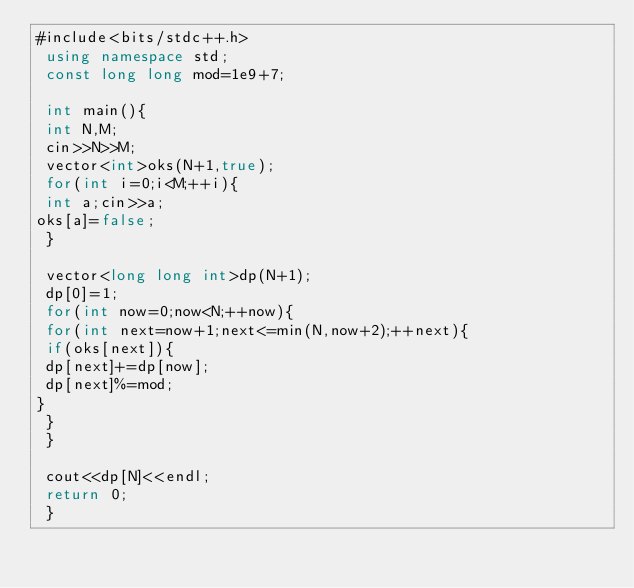<code> <loc_0><loc_0><loc_500><loc_500><_C#_>#include<bits/stdc++.h>
 using namespace std;
 const long long mod=1e9+7;

 int main(){
 int N,M;
 cin>>N>>M;
 vector<int>oks(N+1,true);
 for(int i=0;i<M;++i){
 int a;cin>>a;
oks[a]=false;
 }

 vector<long long int>dp(N+1);
 dp[0]=1;
 for(int now=0;now<N;++now){
 for(int next=now+1;next<=min(N,now+2);++next){
 if(oks[next]){
 dp[next]+=dp[now];
 dp[next]%=mod;
}
 }
 }

 cout<<dp[N]<<endl;
 return 0;
 }</code> 